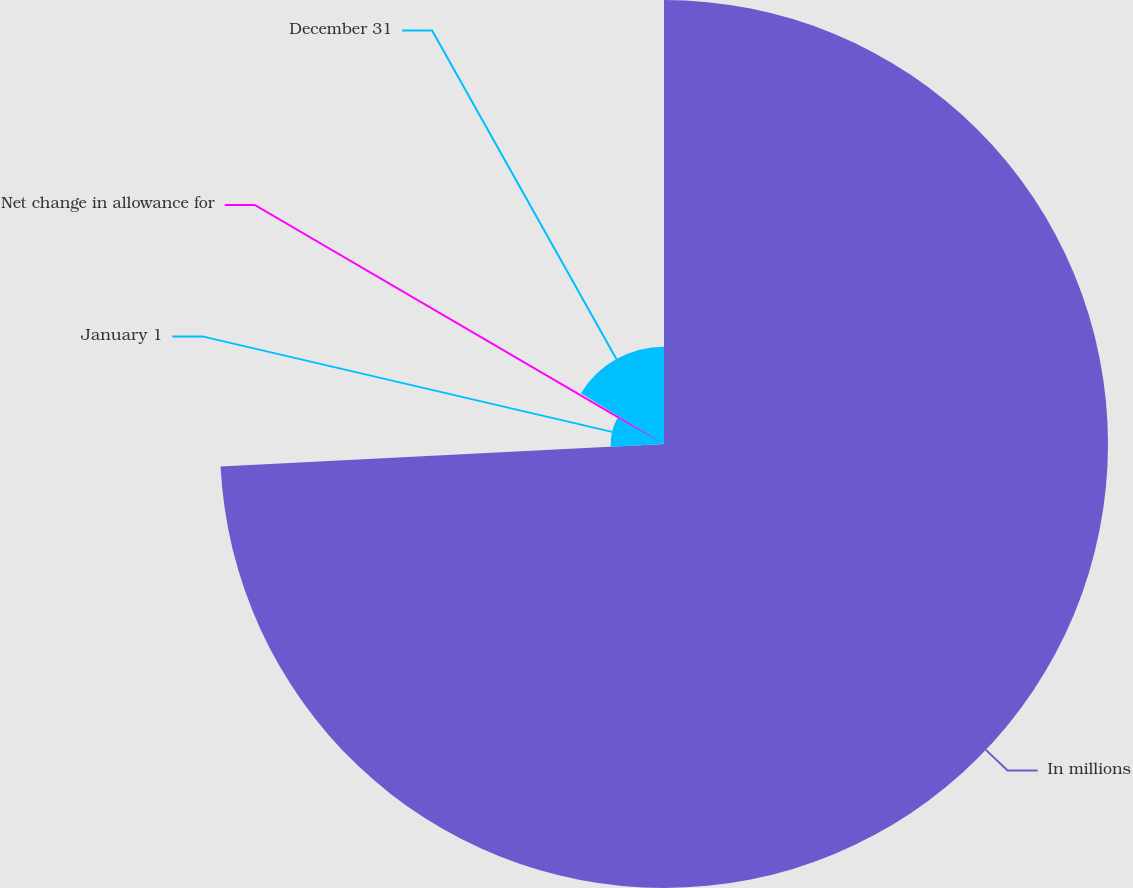<chart> <loc_0><loc_0><loc_500><loc_500><pie_chart><fcel>In millions<fcel>January 1<fcel>Net change in allowance for<fcel>December 31<nl><fcel>74.19%<fcel>8.91%<fcel>0.63%<fcel>16.27%<nl></chart> 